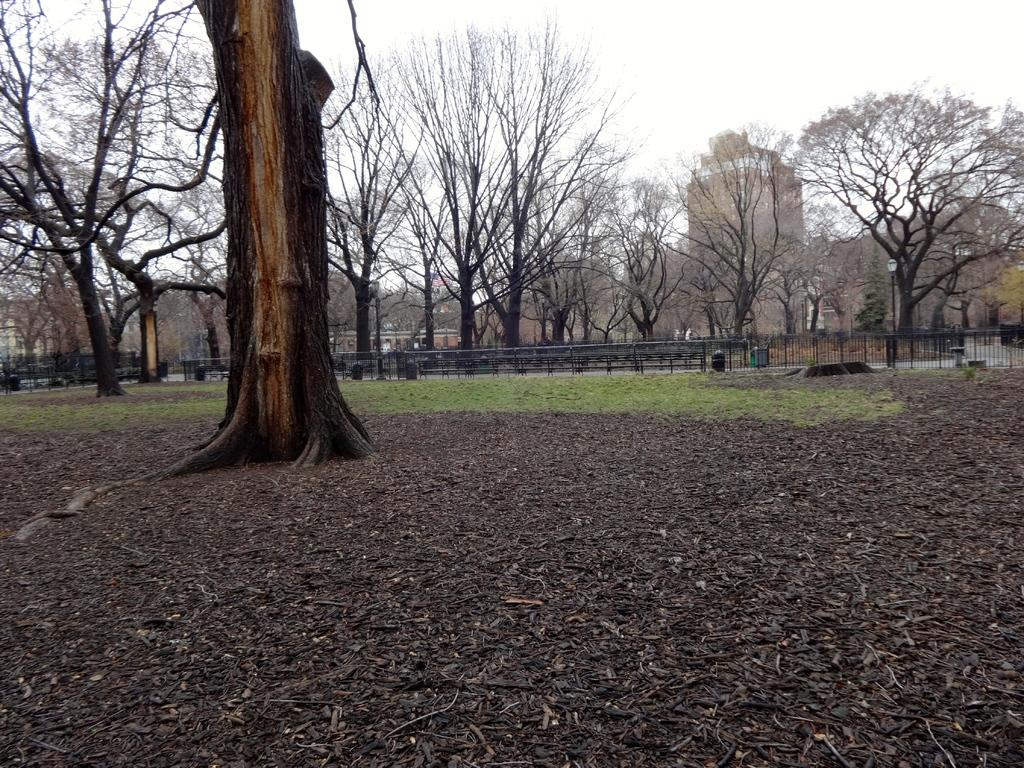What type of vegetation can be seen in the image? There are trees in the image. What is the purpose of the fence in the image? The purpose of the fence in the image is not clear, but it could be for enclosing an area or marking a boundary. What is the ground like in the image? The ground is visible in the image. What are the wooden sticks used for in the image? The wooden sticks could be used for various purposes, such as supporting plants or marking a path. What structures can be seen behind the trees in the image? There are buildings visible behind the trees in the image. What part of the natural environment is visible in the image? The sky is visible in the image. How does the parent express love for their child in the image? There is no parent or child present in the image, so it is not possible to answer this question. What type of pain is depicted in the image? There is no indication of pain or any negative emotion in the image. 